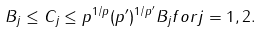Convert formula to latex. <formula><loc_0><loc_0><loc_500><loc_500>B _ { j } \leq C _ { j } \leq p ^ { 1 / p } ( p ^ { \prime } ) ^ { 1 / p ^ { \prime } } B _ { j } f o r j = 1 , 2 .</formula> 